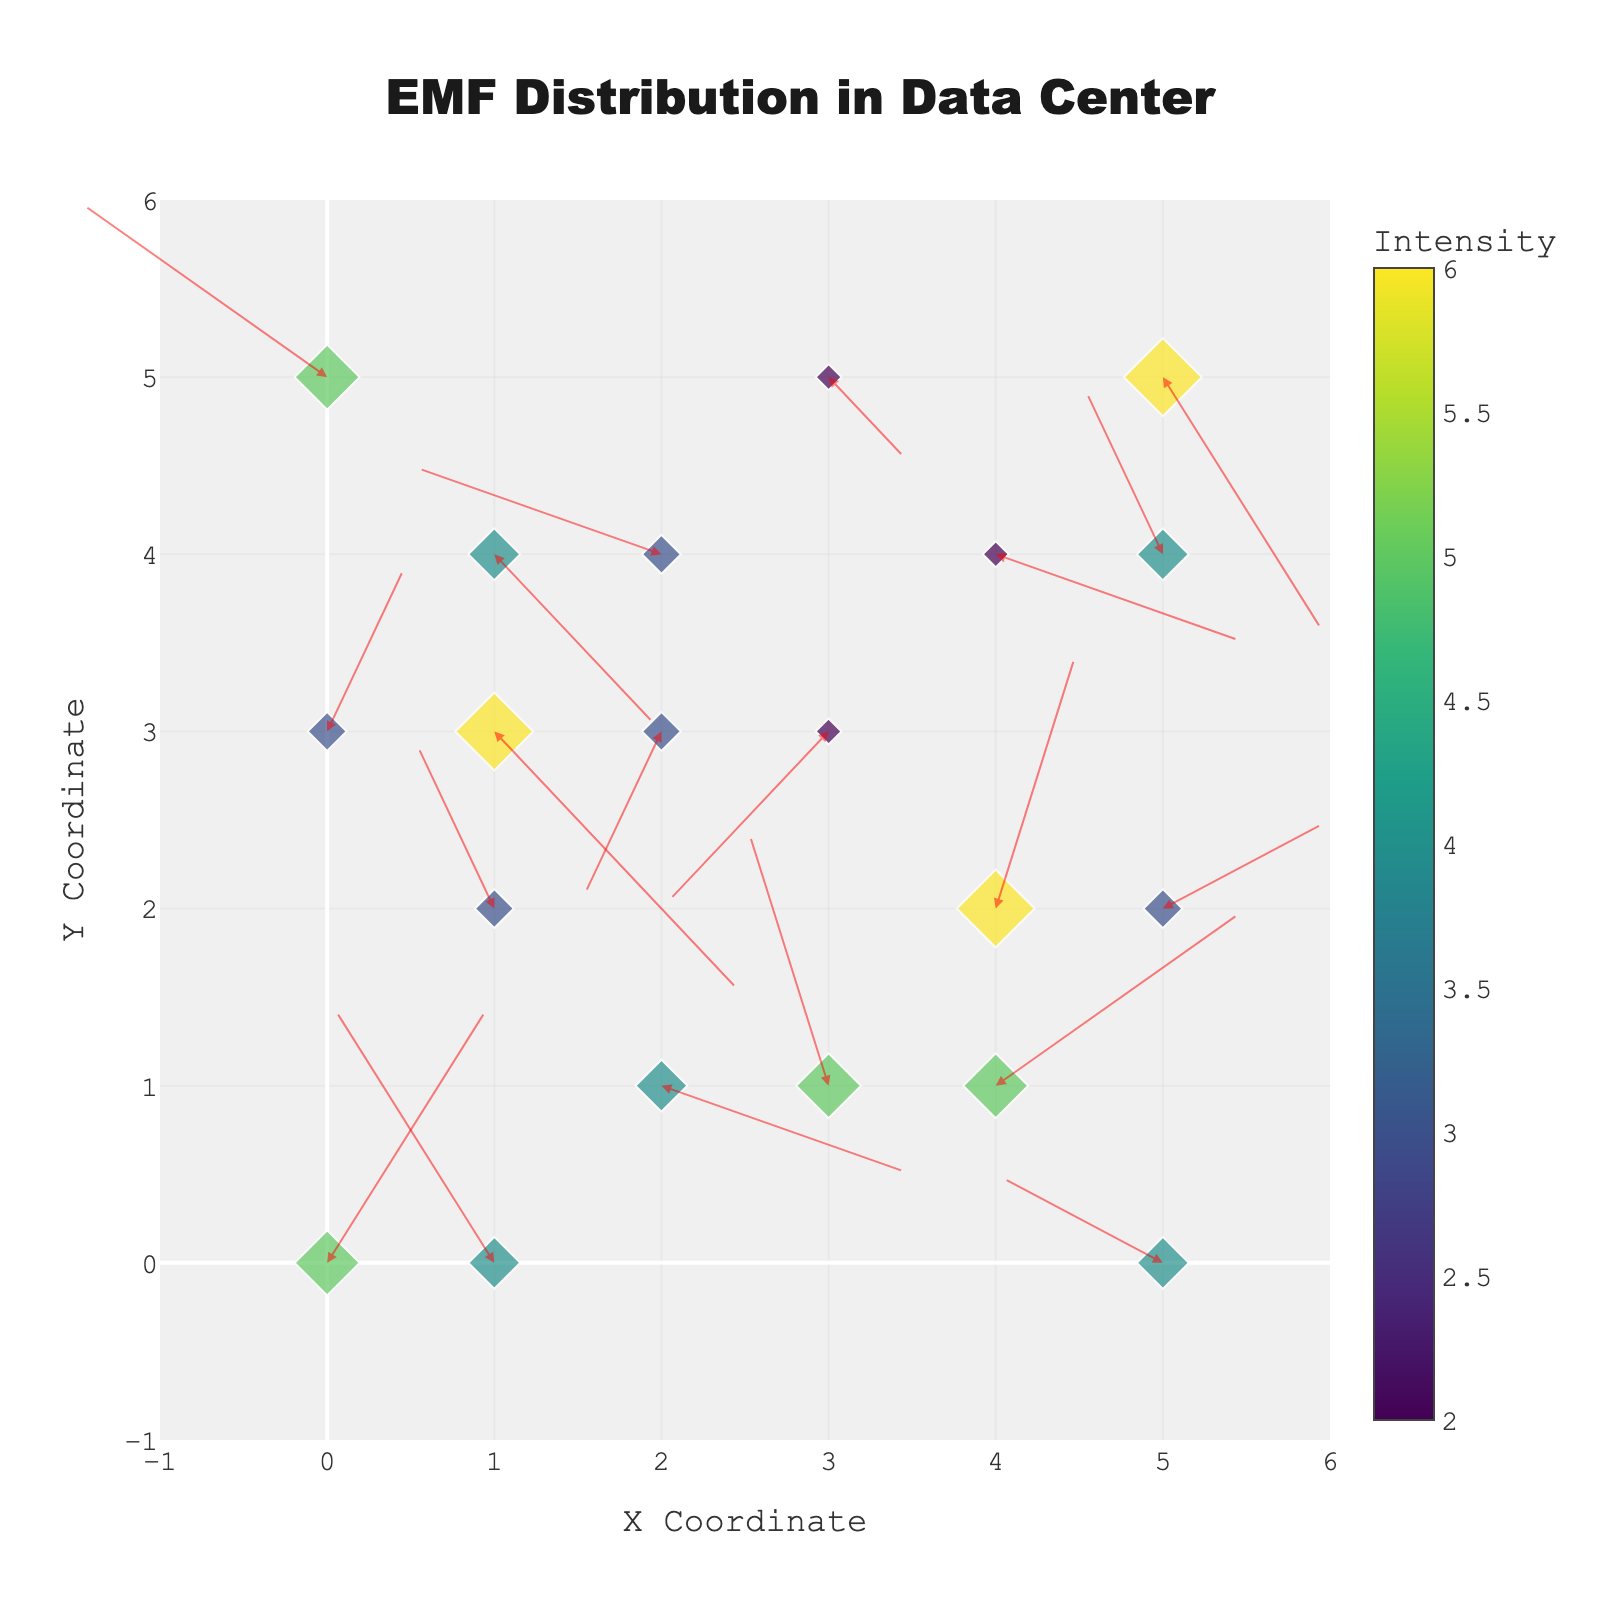how many arrows are there in the plot? Count the number of arrows visually present in the figure. Each arrow represents a combination of coordinates (x, y) and direction vectors (u, v).
Answer: 20 Which location has the highest electromagnetic field intensity? Look for the diamond marker that is the largest and the most intense color in the figure.
Answer: (4, 2) What is the general direction of the electromagnetic field at point (3, 3)? Identify the arrow located at (3, 3); observe the direction it points towards relative to the x and y axes.
Answer: Toward the bottom-left Compare the electromagnetic field intensity between points (2, 4) and (5, 5). Which one is higher? Look at the size and color of the diamond markers at these points. The point with the larger size and/or more intense color has the higher intensity.
Answer: (5, 5) is higher What is the median intensity of the electromagnetic field values? List all the intensity values, sort them, and find the middle value. The values are: 2, 2, 2, 3, 3, 3, 3, 3, 4, 4, 4, 4, 5, 5, 5, 5, 5, 6, 6, 6. The median is the middle one in this sorted list.
Answer: 4 Which direction does the arrow at (0, 0) point towards? Locate the arrow at coordinates (0, 0) and observe its direction.
Answer: Upward-right What is the average electromagnetic field intensity across all points? Sum up all intensity values and divide by the number of data points. The sum of intensities is 81, and there are 20 data points, so the average is 81 / 20.
Answer: 4.05 Compare the total horizontal displacement (u component) for points along the y-axis with y=2 and y=3. Which one is greater? Calculate the sum of horizontal displacement (u) for all points where y = 2 and y = 3, then compare. For y=2 (u values: -1, 1, 2), the sum is 2. For y=3 (u values: 3, -1, 3), the sum is 5. The y=3 has greater total horizontal displacement.
Answer: y=3 